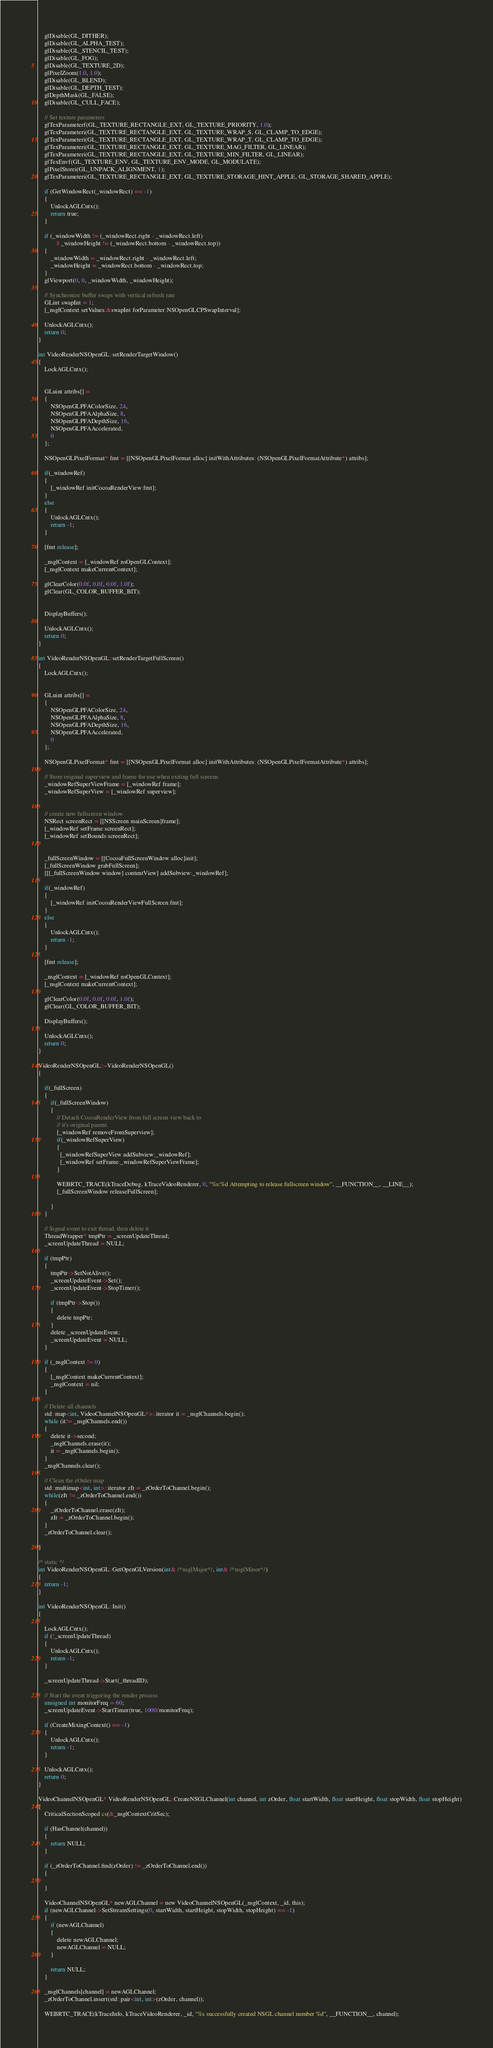<code> <loc_0><loc_0><loc_500><loc_500><_ObjectiveC_>    glDisable(GL_DITHER);
    glDisable(GL_ALPHA_TEST);
    glDisable(GL_STENCIL_TEST);
    glDisable(GL_FOG);
    glDisable(GL_TEXTURE_2D);
    glPixelZoom(1.0, 1.0);
    glDisable(GL_BLEND);
    glDisable(GL_DEPTH_TEST);
    glDepthMask(GL_FALSE);
    glDisable(GL_CULL_FACE);

    // Set texture parameters
    glTexParameterf(GL_TEXTURE_RECTANGLE_EXT, GL_TEXTURE_PRIORITY, 1.0);
    glTexParameteri(GL_TEXTURE_RECTANGLE_EXT, GL_TEXTURE_WRAP_S, GL_CLAMP_TO_EDGE);
    glTexParameteri(GL_TEXTURE_RECTANGLE_EXT, GL_TEXTURE_WRAP_T, GL_CLAMP_TO_EDGE);
    glTexParameteri(GL_TEXTURE_RECTANGLE_EXT, GL_TEXTURE_MAG_FILTER, GL_LINEAR);
    glTexParameteri(GL_TEXTURE_RECTANGLE_EXT, GL_TEXTURE_MIN_FILTER, GL_LINEAR);
    glTexEnvf(GL_TEXTURE_ENV, GL_TEXTURE_ENV_MODE, GL_MODULATE);
    glPixelStorei(GL_UNPACK_ALIGNMENT, 1);
    glTexParameteri(GL_TEXTURE_RECTANGLE_EXT, GL_TEXTURE_STORAGE_HINT_APPLE, GL_STORAGE_SHARED_APPLE);

    if (GetWindowRect(_windowRect) == -1)
    {
        UnlockAGLCntx();
        return true;
    }

    if (_windowWidth != (_windowRect.right - _windowRect.left)
            || _windowHeight != (_windowRect.bottom - _windowRect.top))
    {
        _windowWidth = _windowRect.right - _windowRect.left;
        _windowHeight = _windowRect.bottom - _windowRect.top;
    }
    glViewport(0, 0, _windowWidth, _windowHeight);

    // Synchronize buffer swaps with vertical refresh rate
    GLint swapInt = 1;
    [_nsglContext setValues:&swapInt forParameter:NSOpenGLCPSwapInterval];

    UnlockAGLCntx();
    return 0;
}

int VideoRenderNSOpenGL::setRenderTargetWindow()
{
    LockAGLCntx();


    GLuint attribs[] =
    {
        NSOpenGLPFAColorSize, 24,
        NSOpenGLPFAAlphaSize, 8,
        NSOpenGLPFADepthSize, 16,
        NSOpenGLPFAAccelerated,
        0
    };

    NSOpenGLPixelFormat* fmt = [[NSOpenGLPixelFormat alloc] initWithAttributes: (NSOpenGLPixelFormatAttribute*) attribs];

    if(_windowRef)
    {
        [_windowRef initCocoaRenderView:fmt];
    }
    else
    {
        UnlockAGLCntx();
        return -1;
    }

    [fmt release];

    _nsglContext = [_windowRef nsOpenGLContext];
    [_nsglContext makeCurrentContext];

    glClearColor(0.0f, 0.0f, 0.0f, 1.0f);
    glClear(GL_COLOR_BUFFER_BIT);


    DisplayBuffers();

    UnlockAGLCntx();
    return 0;
}

int VideoRenderNSOpenGL::setRenderTargetFullScreen()
{
    LockAGLCntx();


    GLuint attribs[] =
    {
        NSOpenGLPFAColorSize, 24,
        NSOpenGLPFAAlphaSize, 8,
        NSOpenGLPFADepthSize, 16,
        NSOpenGLPFAAccelerated,
        0
    };

    NSOpenGLPixelFormat* fmt = [[NSOpenGLPixelFormat alloc] initWithAttributes: (NSOpenGLPixelFormatAttribute*) attribs];

    // Store original superview and frame for use when exiting full screens
    _windowRefSuperViewFrame = [_windowRef frame];
    _windowRefSuperView = [_windowRef superview];


    // create new fullscreen window
    NSRect screenRect = [[NSScreen mainScreen]frame];
    [_windowRef setFrame:screenRect];
    [_windowRef setBounds:screenRect];

    
    _fullScreenWindow = [[CocoaFullScreenWindow alloc]init];
    [_fullScreenWindow grabFullScreen];
    [[[_fullScreenWindow window] contentView] addSubview:_windowRef];

    if(_windowRef)
    {
        [_windowRef initCocoaRenderViewFullScreen:fmt];
    }
    else
    {
        UnlockAGLCntx();
        return -1;
    }

    [fmt release];

    _nsglContext = [_windowRef nsOpenGLContext];
    [_nsglContext makeCurrentContext];

    glClearColor(0.0f, 0.0f, 0.0f, 1.0f);
    glClear(GL_COLOR_BUFFER_BIT);

    DisplayBuffers();

    UnlockAGLCntx();
    return 0;
}

VideoRenderNSOpenGL::~VideoRenderNSOpenGL()
{

    if(_fullScreen)
    {
        if(_fullScreenWindow)
        {
            // Detach CocoaRenderView from full screen view back to 
            // it's original parent.
            [_windowRef removeFromSuperview];
            if(_windowRefSuperView) 
            {
              [_windowRefSuperView addSubview:_windowRef];
              [_windowRef setFrame:_windowRefSuperViewFrame];
            }
            
            WEBRTC_TRACE(kTraceDebug, kTraceVideoRenderer, 0, "%s:%d Attempting to release fullscreen window", __FUNCTION__, __LINE__);
            [_fullScreenWindow releaseFullScreen];
     
        }
    }

    // Signal event to exit thread, then delete it
    ThreadWrapper* tmpPtr = _screenUpdateThread;
    _screenUpdateThread = NULL;

    if (tmpPtr)
    {
        tmpPtr->SetNotAlive();
        _screenUpdateEvent->Set();
        _screenUpdateEvent->StopTimer();

        if (tmpPtr->Stop())
        {
            delete tmpPtr;
        }
        delete _screenUpdateEvent;
        _screenUpdateEvent = NULL;
    }

    if (_nsglContext != 0)
    {
        [_nsglContext makeCurrentContext];
        _nsglContext = nil;
    }

    // Delete all channels
    std::map<int, VideoChannelNSOpenGL*>::iterator it = _nsglChannels.begin();
    while (it!= _nsglChannels.end())
    {
        delete it->second;
        _nsglChannels.erase(it);
        it = _nsglChannels.begin();
    }
    _nsglChannels.clear();

    // Clean the zOrder map
    std::multimap<int, int>::iterator zIt = _zOrderToChannel.begin();
    while(zIt != _zOrderToChannel.end())
    {
        _zOrderToChannel.erase(zIt);
        zIt = _zOrderToChannel.begin();
    }
    _zOrderToChannel.clear();

}

/* static */
int VideoRenderNSOpenGL::GetOpenGLVersion(int& /*nsglMajor*/, int& /*nsglMinor*/)
{
    return -1;
}

int VideoRenderNSOpenGL::Init()
{

    LockAGLCntx();
    if (!_screenUpdateThread)
    {
        UnlockAGLCntx();
        return -1;
    }

    _screenUpdateThread->Start(_threadID);

    // Start the event triggering the render process
    unsigned int monitorFreq = 60;
    _screenUpdateEvent->StartTimer(true, 1000/monitorFreq);

    if (CreateMixingContext() == -1)
    {
        UnlockAGLCntx();
        return -1;
    }

    UnlockAGLCntx();
    return 0;
}

VideoChannelNSOpenGL* VideoRenderNSOpenGL::CreateNSGLChannel(int channel, int zOrder, float startWidth, float startHeight, float stopWidth, float stopHeight)
{
    CriticalSectionScoped cs(&_nsglContextCritSec);

    if (HasChannel(channel))
    {
        return NULL;
    }

    if (_zOrderToChannel.find(zOrder) != _zOrderToChannel.end())
    {

    }

    VideoChannelNSOpenGL* newAGLChannel = new VideoChannelNSOpenGL(_nsglContext, _id, this);
    if (newAGLChannel->SetStreamSettings(0, startWidth, startHeight, stopWidth, stopHeight) == -1)
    {
        if (newAGLChannel)
        {
            delete newAGLChannel;
            newAGLChannel = NULL;
        }

        return NULL;
    }

    _nsglChannels[channel] = newAGLChannel;
    _zOrderToChannel.insert(std::pair<int, int>(zOrder, channel));

    WEBRTC_TRACE(kTraceInfo, kTraceVideoRenderer, _id, "%s successfully created NSGL channel number %d", __FUNCTION__, channel);
</code> 